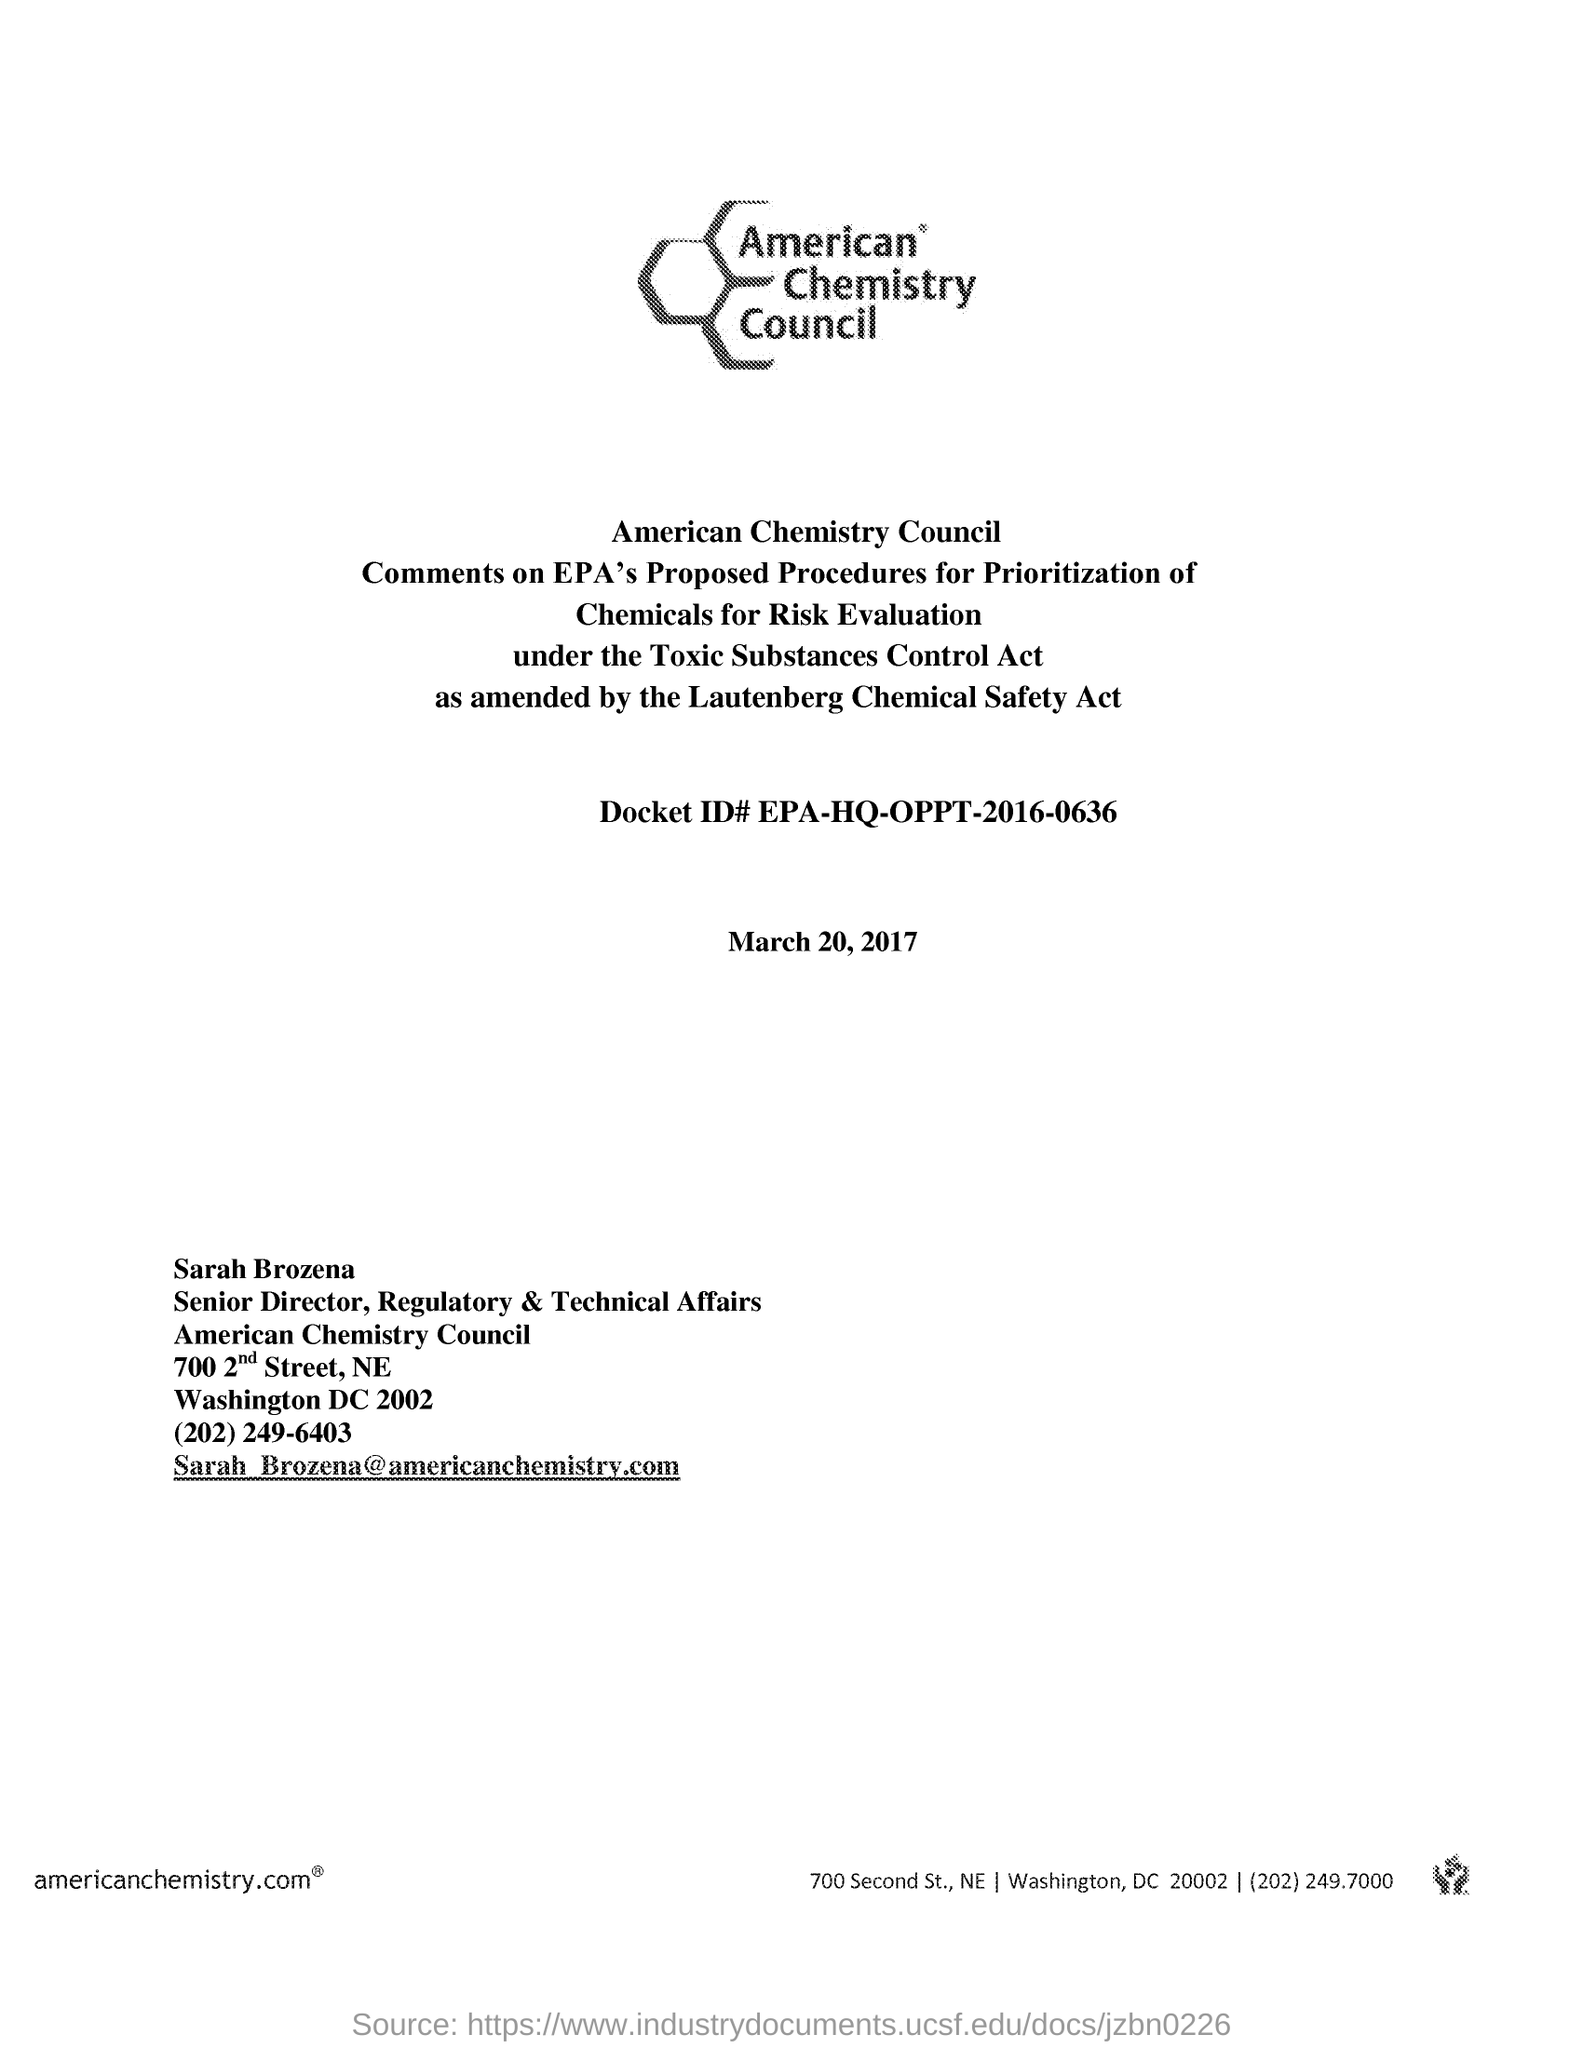Indicate a few pertinent items in this graphic. The email provided at the bottom of the document is "[sarah\_brozena@americanchemistry.com](mailto:sarah_brozena@americanchemistry.com)". The date on the document is March 20, 2017. Sarah Brozena is the Senior Director of Regulatory and Technical Affairs at the American Chemistry Council. Sarah Brozena is the Senior Director of Regulatory and Technical Affairs at the American Chemistry Council. 